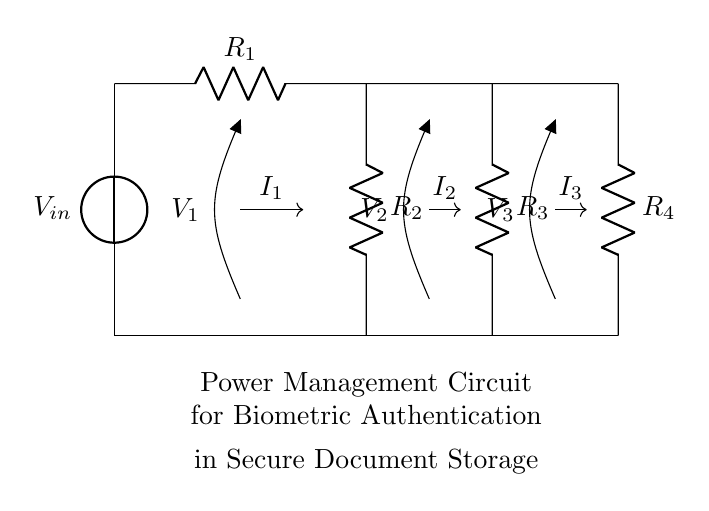What is the total number of resistors in this circuit? There are four resistors labeled as R1, R2, R3, and R4 in the circuit diagram.
Answer: 4 What type of circuit is displayed? The circuit is a current divider circuit, which distributes input current among multiple resistors connected in parallel.
Answer: Current divider What are the labels of the nodes measuring voltage? The nodes measuring voltage are labeled V1, V2, and V3, each associated with one of the resistors in the circuit.
Answer: V1, V2, V3 What is the voltage source in this circuit? The voltage source is labeled as Vin, which provides the input voltage to the entire circuit.
Answer: Vin How is the total current divided among the resistors? The total current entering the circuit is divided inversely proportional to the resistance values, meaning lower resistance draws higher current.
Answer: Inversely proportional What is the configuration of the resistors in this circuit? The resistors are connected in parallel, as each resistor has its ends connected to the same two nodes.
Answer: Parallel What does the notation “I1, I2, I3” represent in the circuit? The notation represents the branch currents flowing through resistors R1, R2, and R3 respectively, as part of the current division.
Answer: Branch currents 